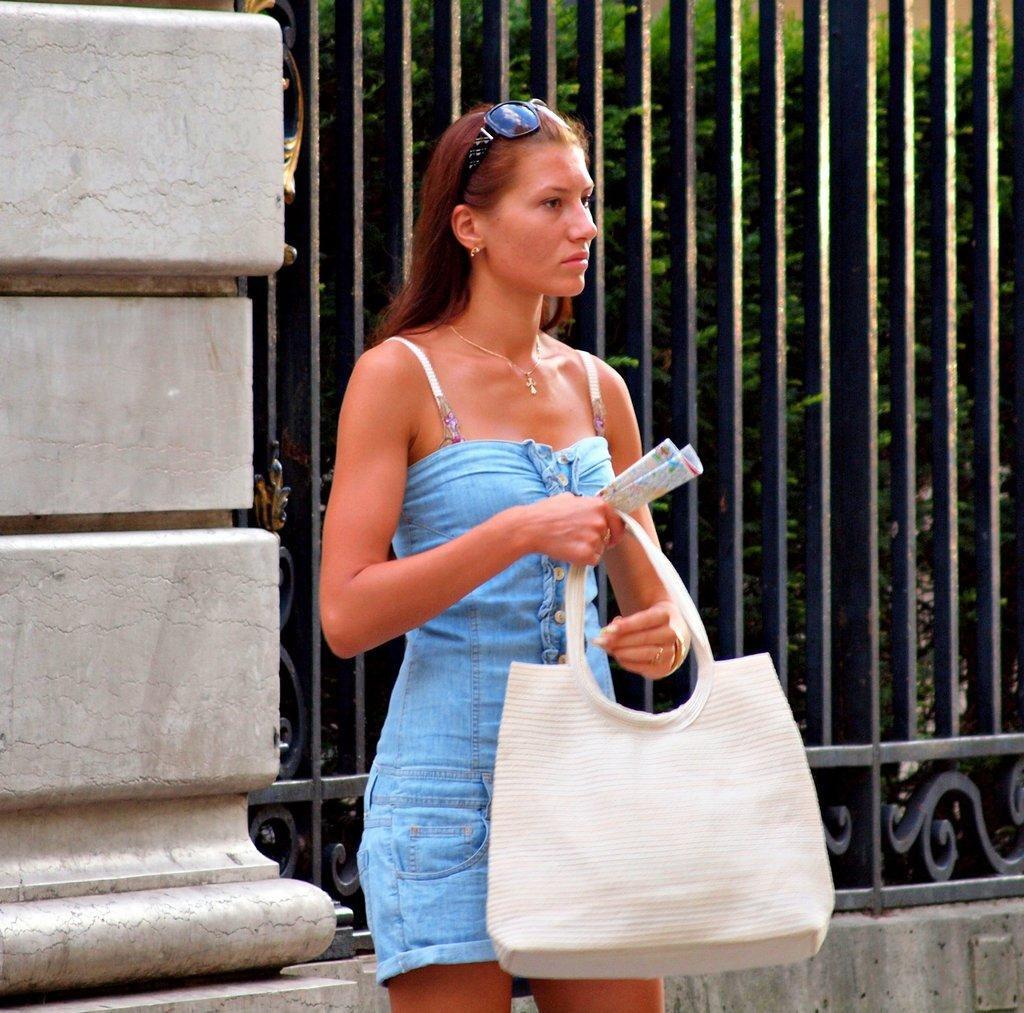What is the main subject of the image? There is a woman standing in the center of the image. What is the woman holding in her hand? The woman is holding a handbag in her hand. What can be seen in the background of the image? There is a metal fence and a tree in the background of the image. Can you see any bees swimming in the harbor in the image? There is no harbor or bees present in the image. 